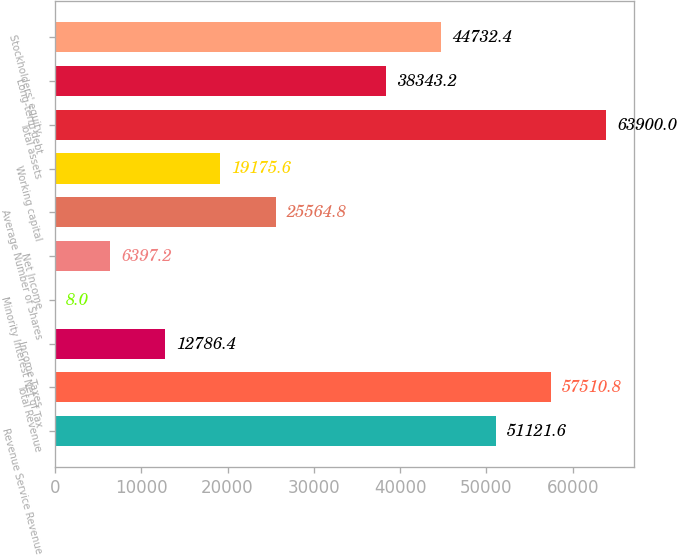Convert chart. <chart><loc_0><loc_0><loc_500><loc_500><bar_chart><fcel>Revenue Service Revenue<fcel>Total Revenue<fcel>Income Taxes<fcel>Minority Interest Net of Tax<fcel>Net Income<fcel>Average Number of Shares<fcel>Working capital<fcel>Total assets<fcel>Long-term debt<fcel>Stockholders' equity<nl><fcel>51121.6<fcel>57510.8<fcel>12786.4<fcel>8<fcel>6397.2<fcel>25564.8<fcel>19175.6<fcel>63900<fcel>38343.2<fcel>44732.4<nl></chart> 